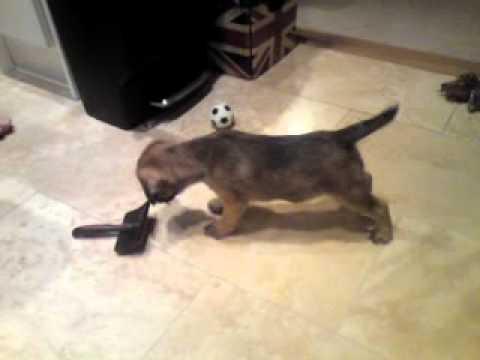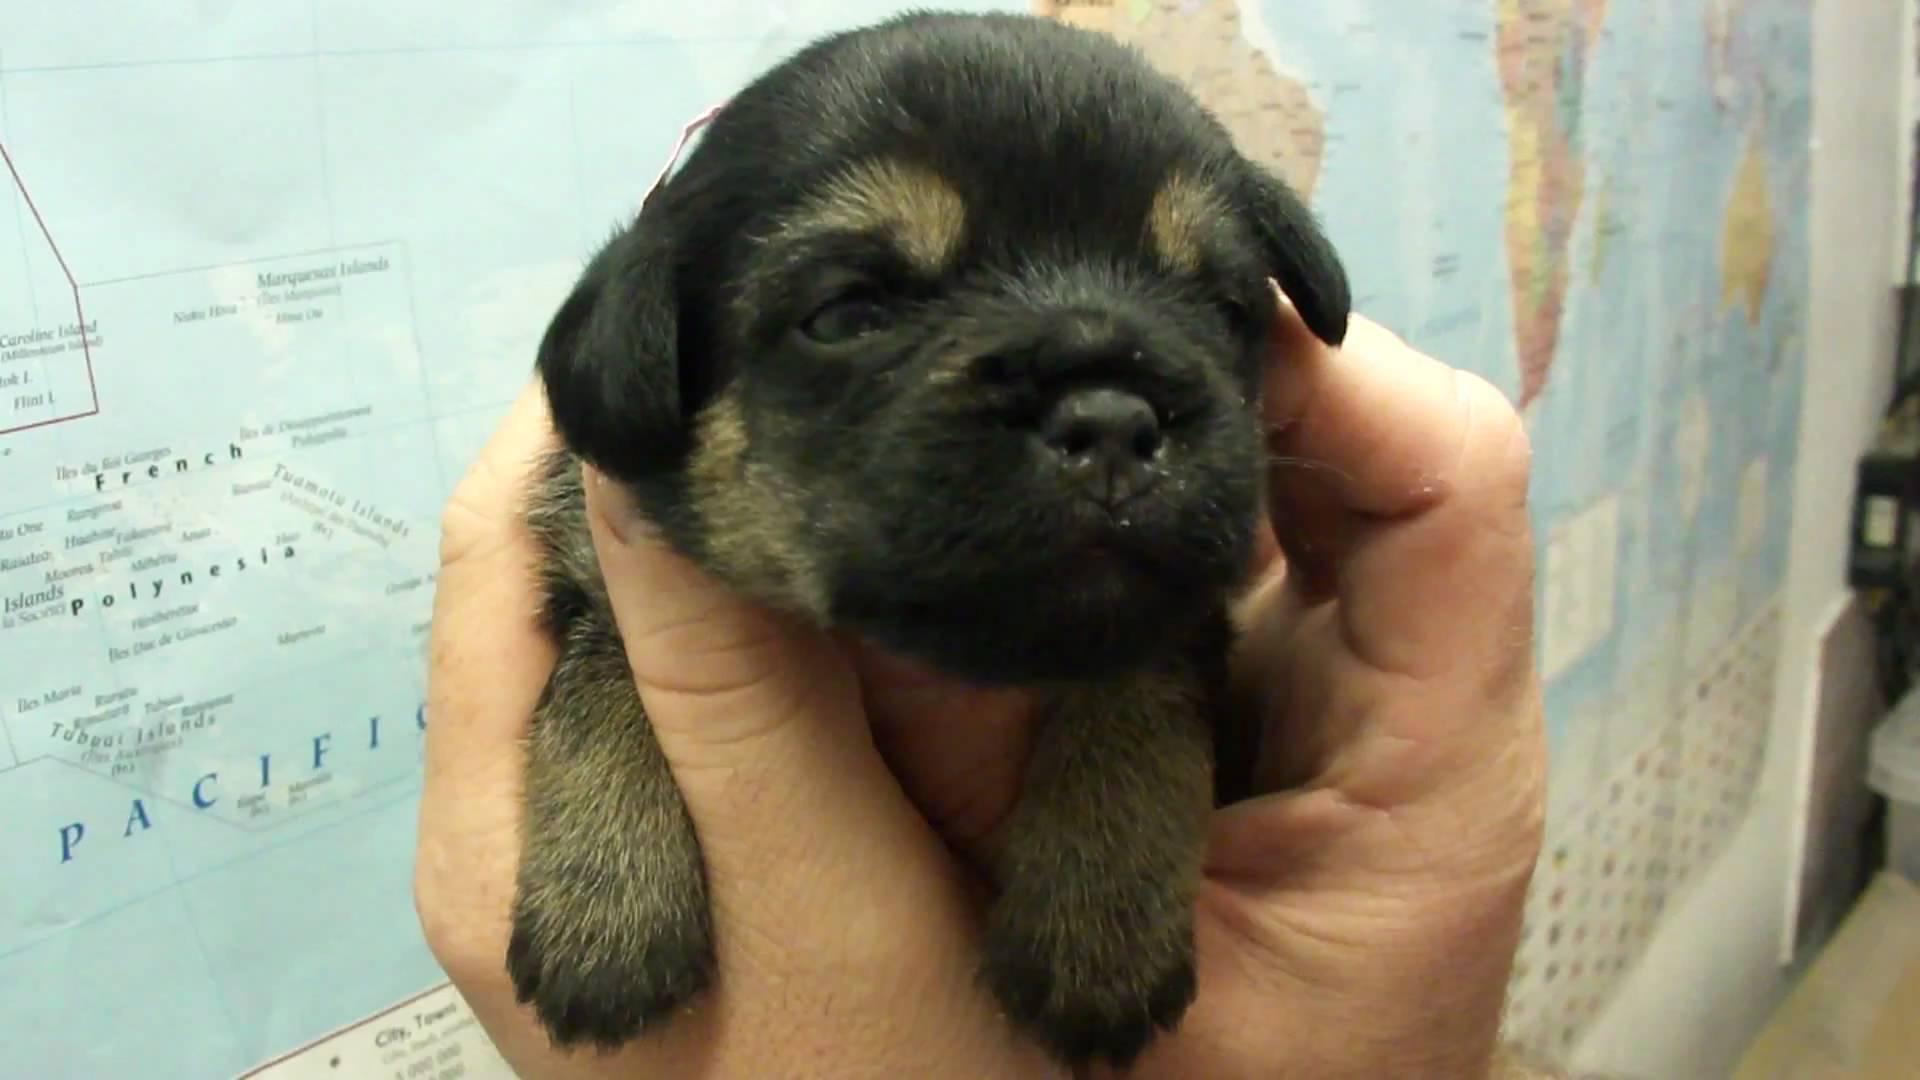The first image is the image on the left, the second image is the image on the right. Assess this claim about the two images: "One image shows a puppy held in a pair of hands, with its front paws draped over a hand.". Correct or not? Answer yes or no. Yes. The first image is the image on the left, the second image is the image on the right. Assess this claim about the two images: "The dog in one of the images is being held in a person's hand.". Correct or not? Answer yes or no. Yes. 